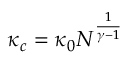Convert formula to latex. <formula><loc_0><loc_0><loc_500><loc_500>\kappa _ { c } = \kappa _ { 0 } N ^ { \frac { 1 } { \gamma - 1 } }</formula> 